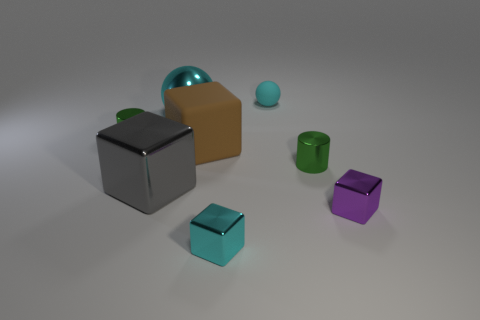Can you tell me the colors of the objects from left to right? From left to right, the objects are gray, gold, blue, green, teal, and purple. 